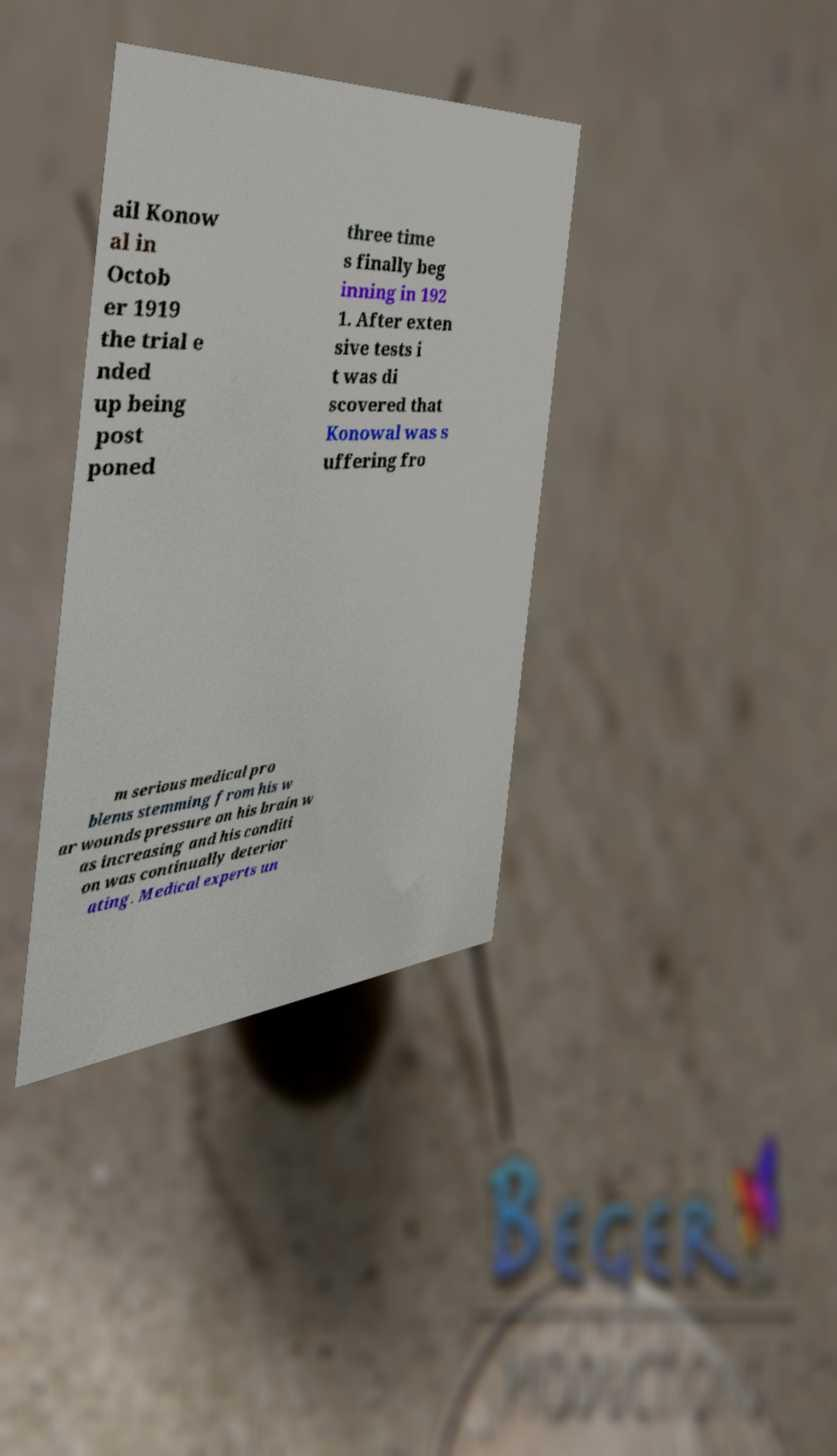Please read and relay the text visible in this image. What does it say? ail Konow al in Octob er 1919 the trial e nded up being post poned three time s finally beg inning in 192 1. After exten sive tests i t was di scovered that Konowal was s uffering fro m serious medical pro blems stemming from his w ar wounds pressure on his brain w as increasing and his conditi on was continually deterior ating. Medical experts un 